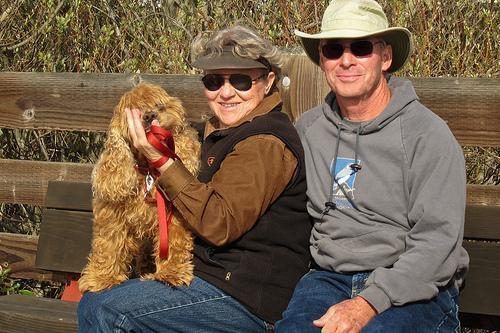How many dogs are in the image?
Give a very brief answer. 1. 